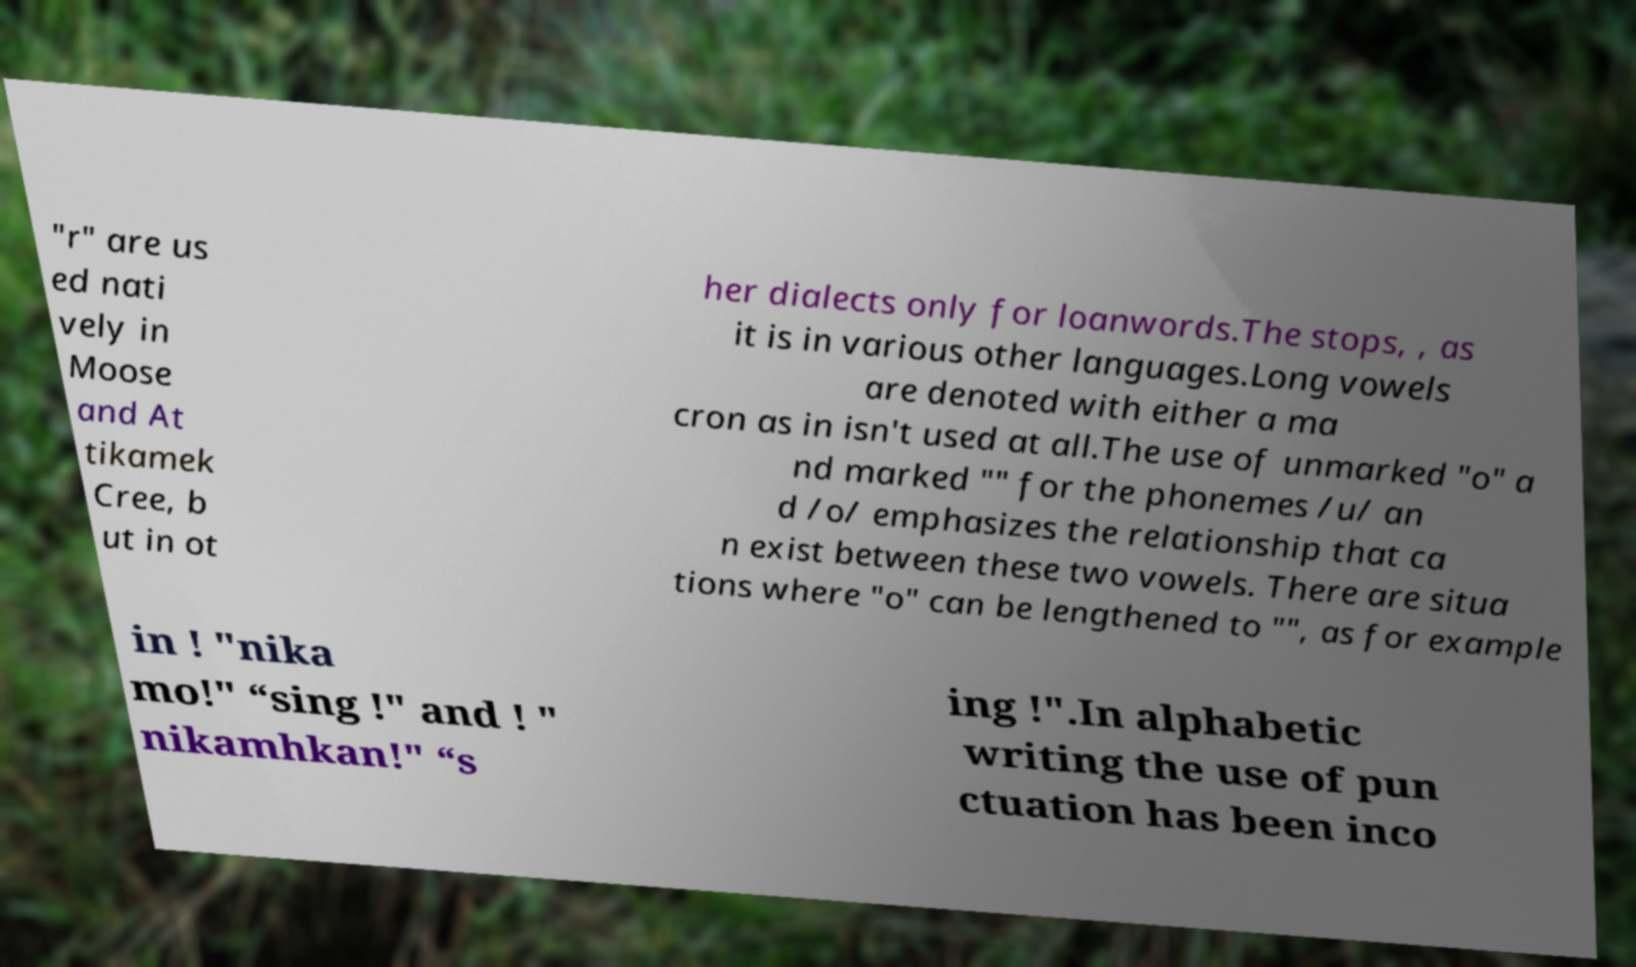What messages or text are displayed in this image? I need them in a readable, typed format. "r" are us ed nati vely in Moose and At tikamek Cree, b ut in ot her dialects only for loanwords.The stops, , as it is in various other languages.Long vowels are denoted with either a ma cron as in isn't used at all.The use of unmarked "o" a nd marked "" for the phonemes /u/ an d /o/ emphasizes the relationship that ca n exist between these two vowels. There are situa tions where "o" can be lengthened to "", as for example in ! "nika mo!" “sing !" and ! " nikamhkan!" “s ing !".In alphabetic writing the use of pun ctuation has been inco 